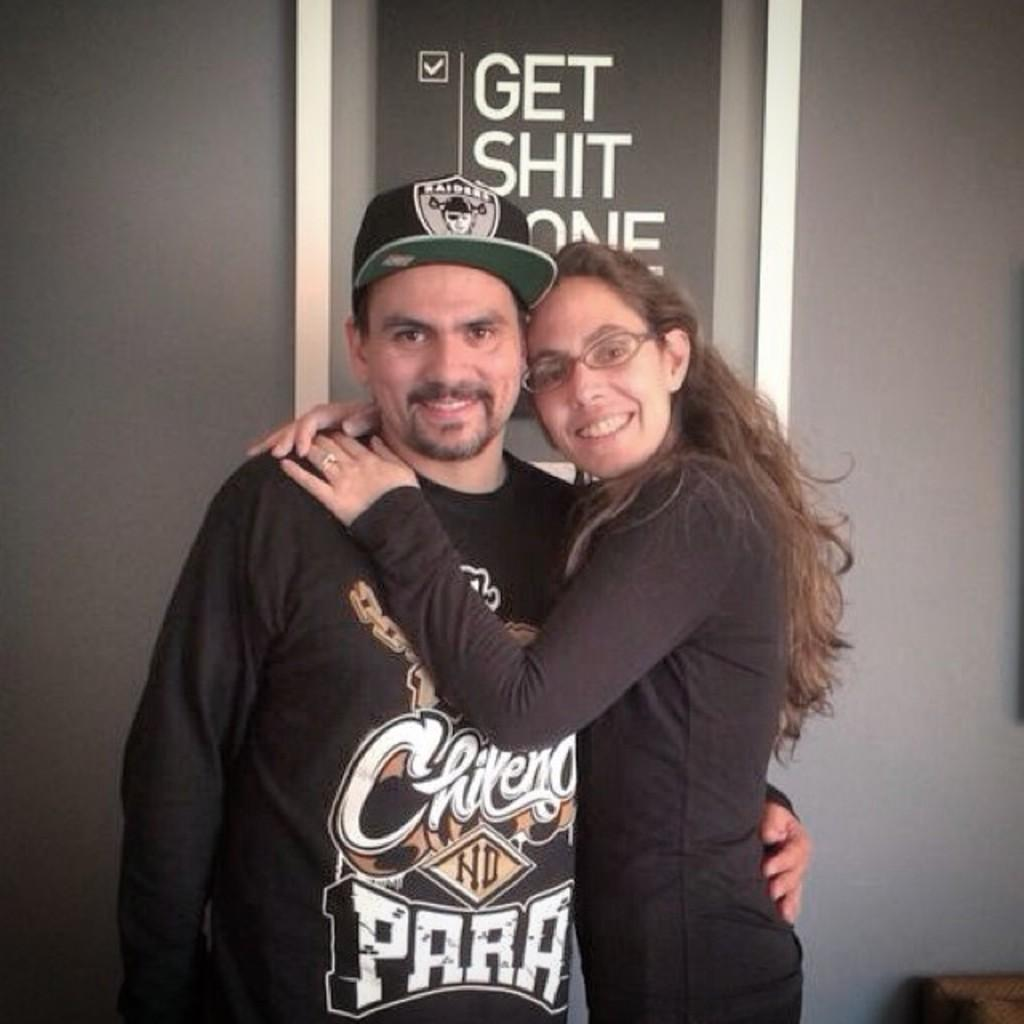<image>
Share a concise interpretation of the image provided. A man in a Raiders hat is hugging a woman wearing glasses. 